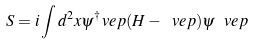<formula> <loc_0><loc_0><loc_500><loc_500>S = i \int d ^ { 2 } x \psi ^ { \dagger } _ { \ } v e p ( H - \ v e p ) \psi _ { \ } v e p</formula> 